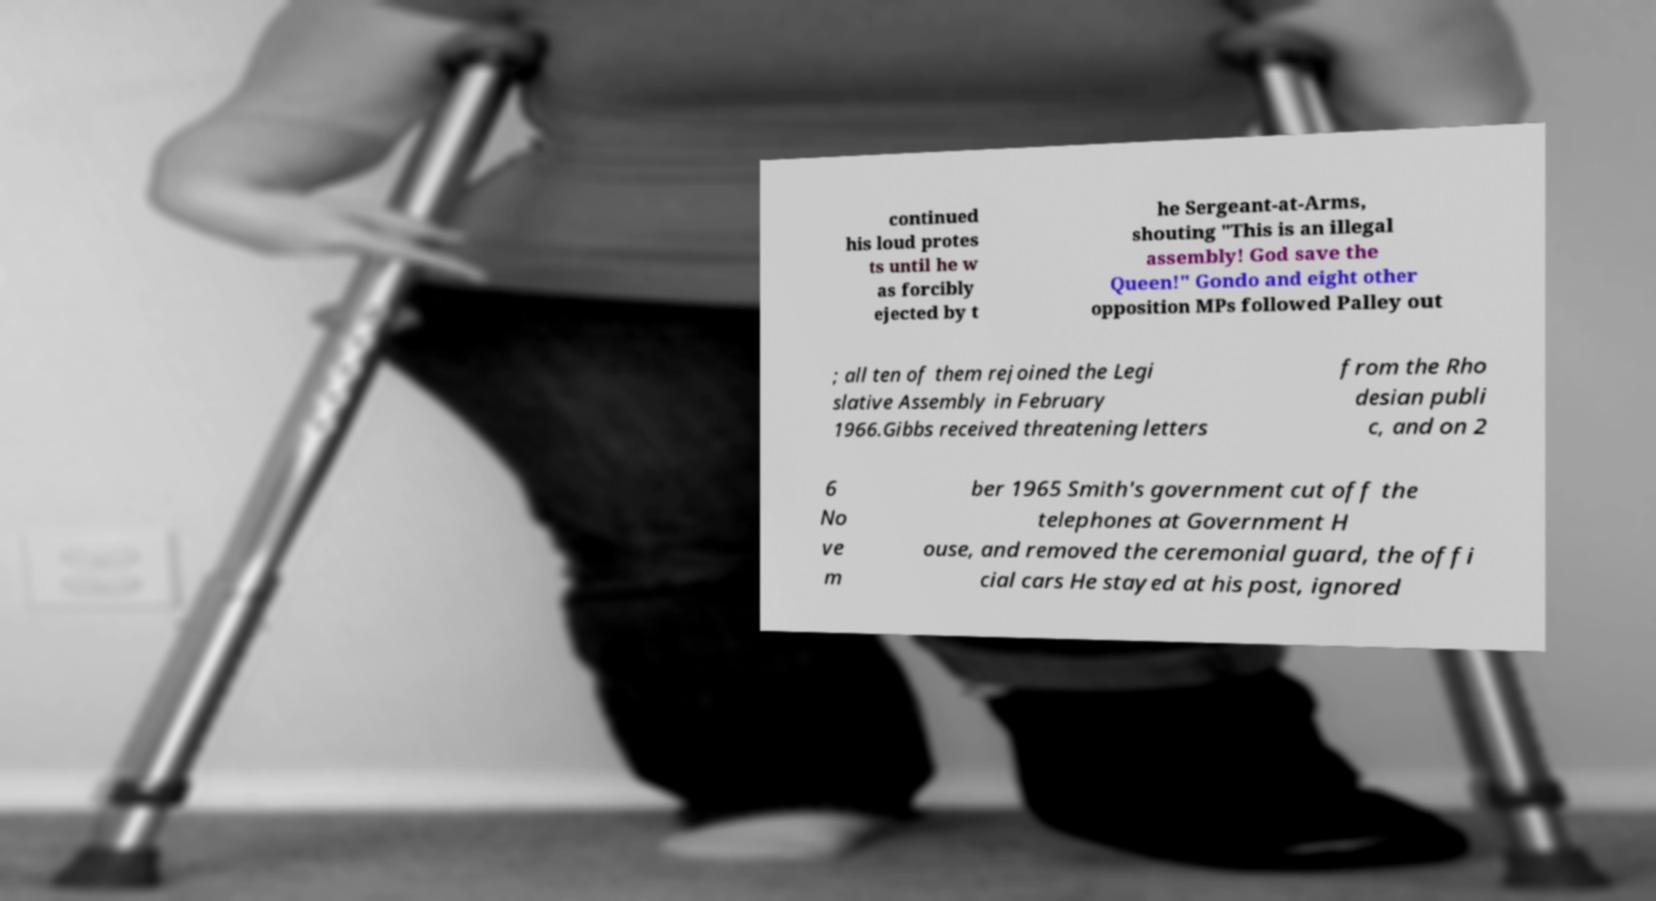Could you extract and type out the text from this image? continued his loud protes ts until he w as forcibly ejected by t he Sergeant-at-Arms, shouting "This is an illegal assembly! God save the Queen!" Gondo and eight other opposition MPs followed Palley out ; all ten of them rejoined the Legi slative Assembly in February 1966.Gibbs received threatening letters from the Rho desian publi c, and on 2 6 No ve m ber 1965 Smith's government cut off the telephones at Government H ouse, and removed the ceremonial guard, the offi cial cars He stayed at his post, ignored 